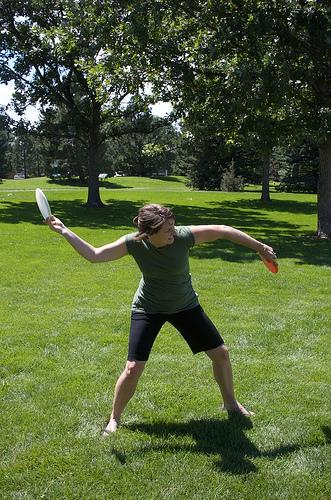What is this woman trying to hit? Please explain your reasoning. ball. She has a frisbee in her hand and will throw it to someone else 